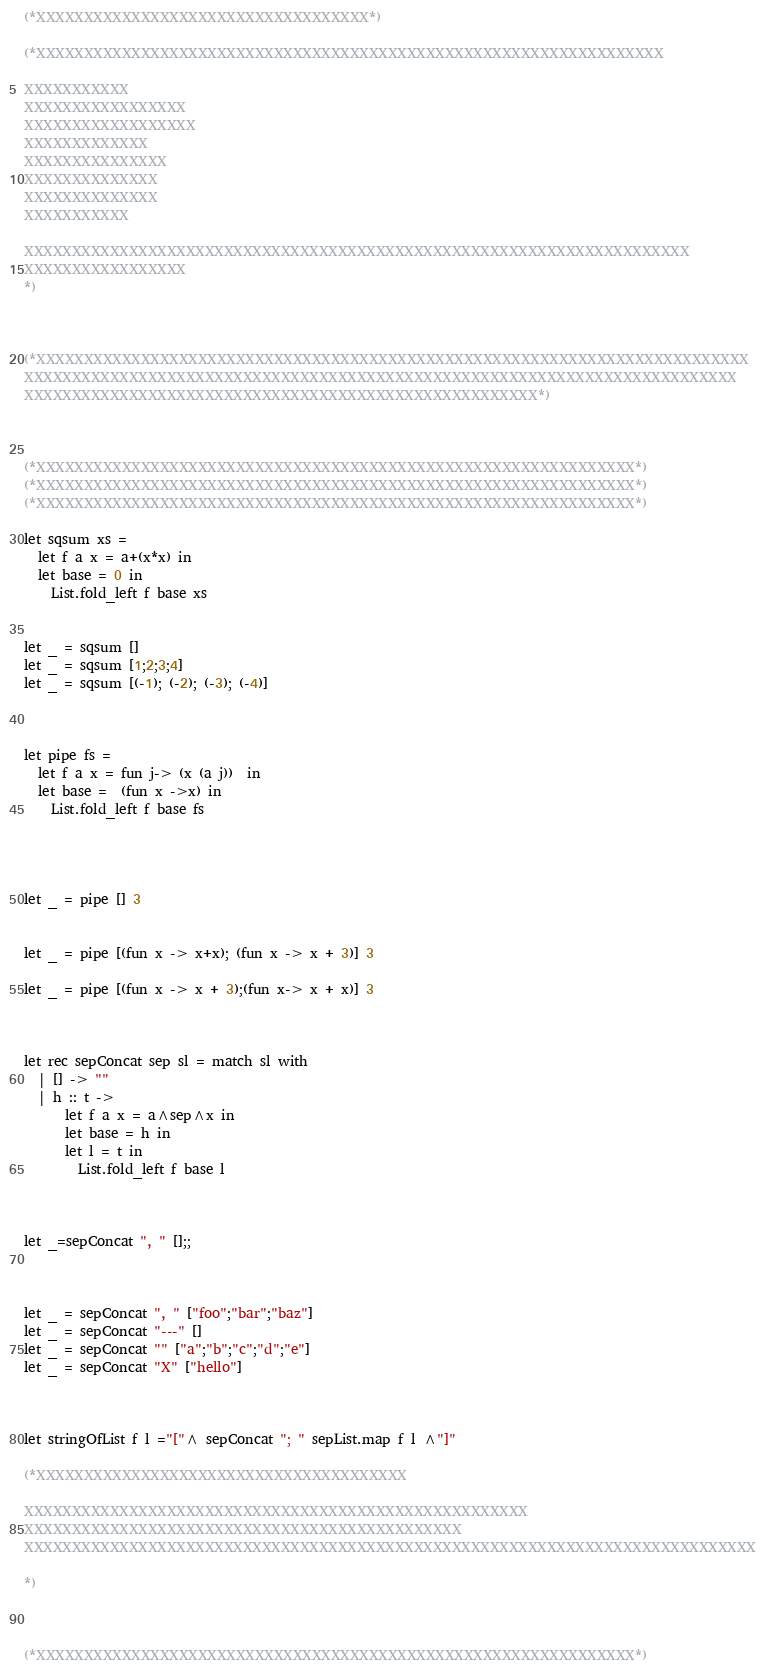Convert code to text. <code><loc_0><loc_0><loc_500><loc_500><_OCaml_>(*XXXXXXXXXXXXXXXXXXXXXXXXXXXXXXXXXXX*)

(*XXXXXXXXXXXXXXXXXXXXXXXXXXXXXXXXXXXXXXXXXXXXXXXXXXXXXXXXXXXXXXXXXX

XXXXXXXXXXX
XXXXXXXXXXXXXXXXX
XXXXXXXXXXXXXXXXXX
XXXXXXXXXXXXX
XXXXXXXXXXXXXXX
XXXXXXXXXXXXXX
XXXXXXXXXXXXXX
XXXXXXXXXXX

XXXXXXXXXXXXXXXXXXXXXXXXXXXXXXXXXXXXXXXXXXXXXXXXXXXXXXXXXXXXXXXXXXXXXX
XXXXXXXXXXXXXXXXX
*)



(*XXXXXXXXXXXXXXXXXXXXXXXXXXXXXXXXXXXXXXXXXXXXXXXXXXXXXXXXXXXXXXXXXXXXXXXXXXX
XXXXXXXXXXXXXXXXXXXXXXXXXXXXXXXXXXXXXXXXXXXXXXXXXXXXXXXXXXXXXXXXXXXXXXXXXXX
XXXXXXXXXXXXXXXXXXXXXXXXXXXXXXXXXXXXXXXXXXXXXXXXXXXXXX*)



(*XXXXXXXXXXXXXXXXXXXXXXXXXXXXXXXXXXXXXXXXXXXXXXXXXXXXXXXXXXXXXXX*)
(*XXXXXXXXXXXXXXXXXXXXXXXXXXXXXXXXXXXXXXXXXXXXXXXXXXXXXXXXXXXXXXX*)
(*XXXXXXXXXXXXXXXXXXXXXXXXXXXXXXXXXXXXXXXXXXXXXXXXXXXXXXXXXXXXXXX*)

let sqsum xs = 
  let f a x = a+(x*x) in
  let base = 0 in
    List.fold_left f base xs


let _ = sqsum []
let _ = sqsum [1;2;3;4]
let _ = sqsum [(-1); (-2); (-3); (-4)]



let pipe fs = 
  let f a x = fun j-> (x (a j))  in
  let base =  (fun x ->x) in 
    List.fold_left f base fs




let _ = pipe [] 3


let _ = pipe [(fun x -> x+x); (fun x -> x + 3)] 3

let _ = pipe [(fun x -> x + 3);(fun x-> x + x)] 3



let rec sepConcat sep sl = match sl with 
  | [] -> ""
  | h :: t -> 
      let f a x = a^sep^x in
      let base = h in
      let l = t in
        List.fold_left f base l



let _=sepConcat ", " [];;



let _ = sepConcat ", " ["foo";"bar";"baz"]
let _ = sepConcat "---" []
let _ = sepConcat "" ["a";"b";"c";"d";"e"]
let _ = sepConcat "X" ["hello"]



let stringOfList f l ="["^ sepConcat "; " sepList.map f l ^"]"

(*XXXXXXXXXXXXXXXXXXXXXXXXXXXXXXXXXXXXXXX

XXXXXXXXXXXXXXXXXXXXXXXXXXXXXXXXXXXXXXXXXXXXXXXXXXXXX
XXXXXXXXXXXXXXXXXXXXXXXXXXXXXXXXXXXXXXXXXXXXXX
XXXXXXXXXXXXXXXXXXXXXXXXXXXXXXXXXXXXXXXXXXXXXXXXXXXXXXXXXXXXXXXXXXXXXXXXXXXXX

*)



(*XXXXXXXXXXXXXXXXXXXXXXXXXXXXXXXXXXXXXXXXXXXXXXXXXXXXXXXXXXXXXXX*)</code> 